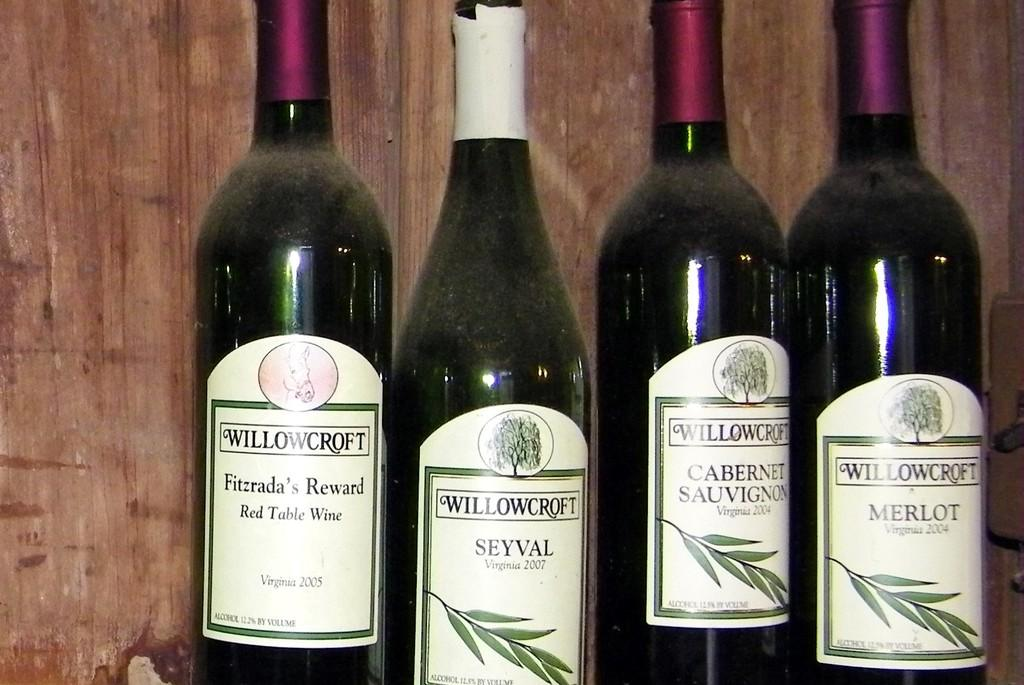<image>
Offer a succinct explanation of the picture presented. Four bottles of wine by Willowcroft sit side by side. 